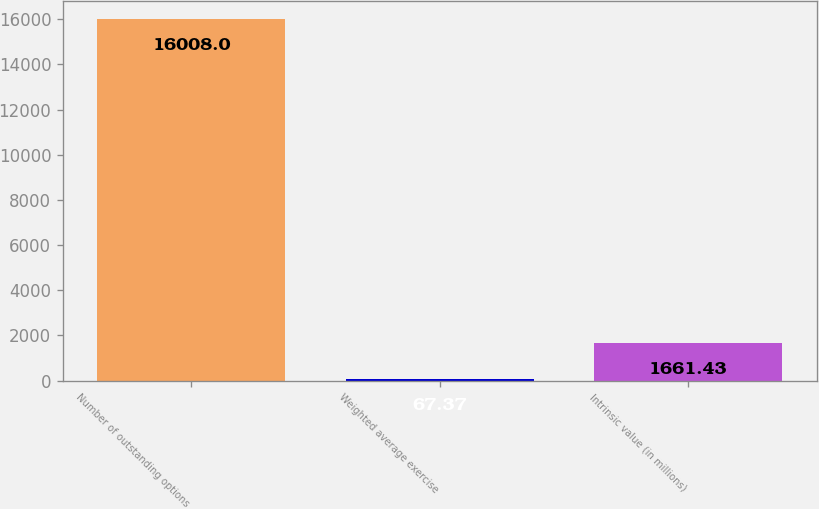Convert chart. <chart><loc_0><loc_0><loc_500><loc_500><bar_chart><fcel>Number of outstanding options<fcel>Weighted average exercise<fcel>Intrinsic value (in millions)<nl><fcel>16008<fcel>67.37<fcel>1661.43<nl></chart> 